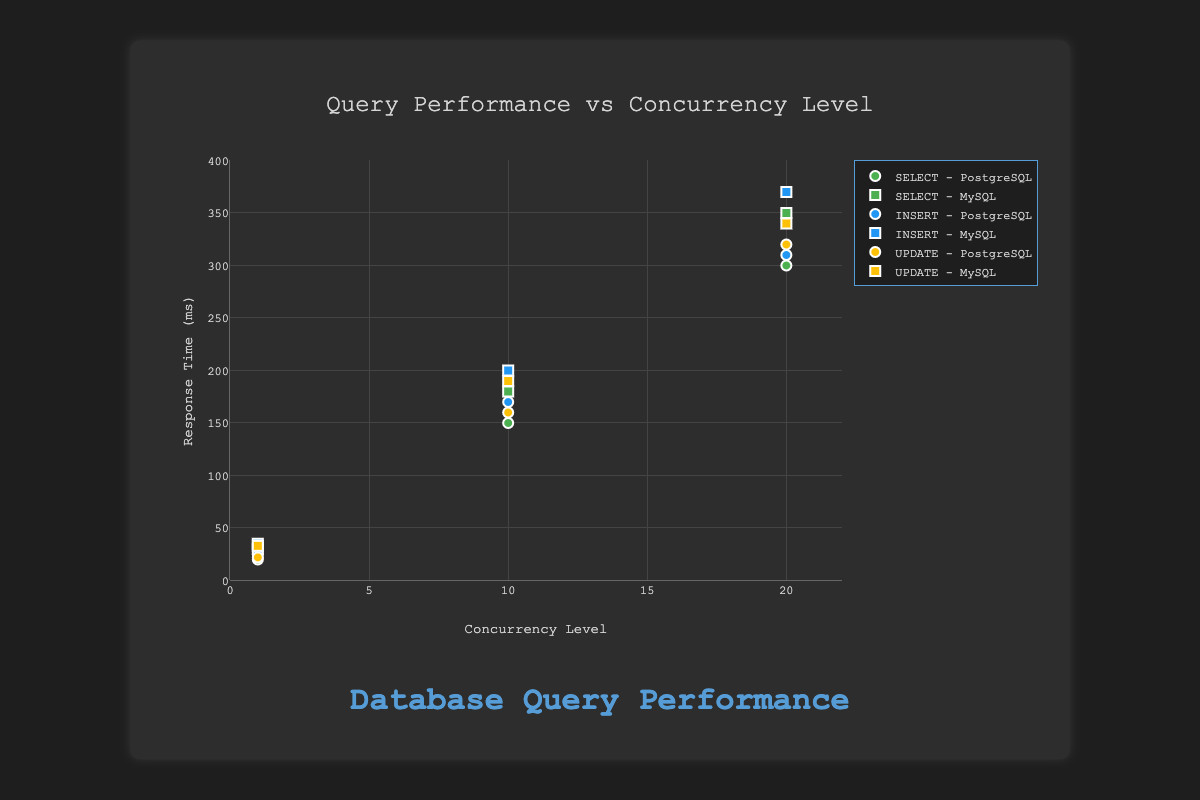What's the title of the scatter plot? The title is displayed at the top of the scatter plot.
Answer: Query Performance vs Concurrency Level What is the x-axis representing? The x-axis is labeled with the title 'Concurrency Level' and ranges from 0 to 22.
Answer: Concurrency Level What is the y-axis representing? The y-axis is labeled with the title 'Response Time (ms)' and ranges from 0 to 400.
Answer: Response Time (ms) How many data points are plotted for PostgreSQL SELECT queries? By looking at the markers on the plot for the PostgreSQL SELECT queries, we see three data points, corresponding to concurrency levels 1, 10, and 20.
Answer: 3 Which query type has the highest response time for MySQL at concurrency level 20? For MySQL at concurrency level 20, the INSERT query has the highest response time which is indicated by the marker at y=370.
Answer: INSERT What is the difference in response time for PostgreSQL SELECT queries between concurrency levels 1 and 20? For PostgreSQL SELECT queries, the response time is 20ms at concurrency level 1 and 300ms at concurrency level 20. The difference is 300 - 20.
Answer: 280 ms Does the response time for PostgreSQL UPDATE queries increase or decrease as concurrency level increases from 1 to 20? By observing the trend of the markers for PostgreSQL UPDATE queries, the response time increases consistently from 22ms at concurrency level 1 to 320ms at concurrency level 20.
Answer: Increase Compare the response times for MySQL SELECT and UPDATE queries at concurrency level 10. At concurrency level 10, the response time for MySQL SELECT queries is 180ms and for MySQL UPDATE queries is 190ms. Thus, MySQL SELECT is slightly faster.
Answer: SELECT For SELECT queries, which database shows a faster response time at concurrency level 10? The response time for SELECT queries at concurrency level 10 is faster for PostgreSQL (150ms) compared to MySQL (180ms).
Answer: PostgreSQL What is the average response time for PostgreSQL INSERT queries across all concurrency levels? The response times for PostgreSQL INSERT queries are 25ms, 170ms, and 310ms. The average is (25 + 170 + 310) / 3.
Answer: 168.33 ms 